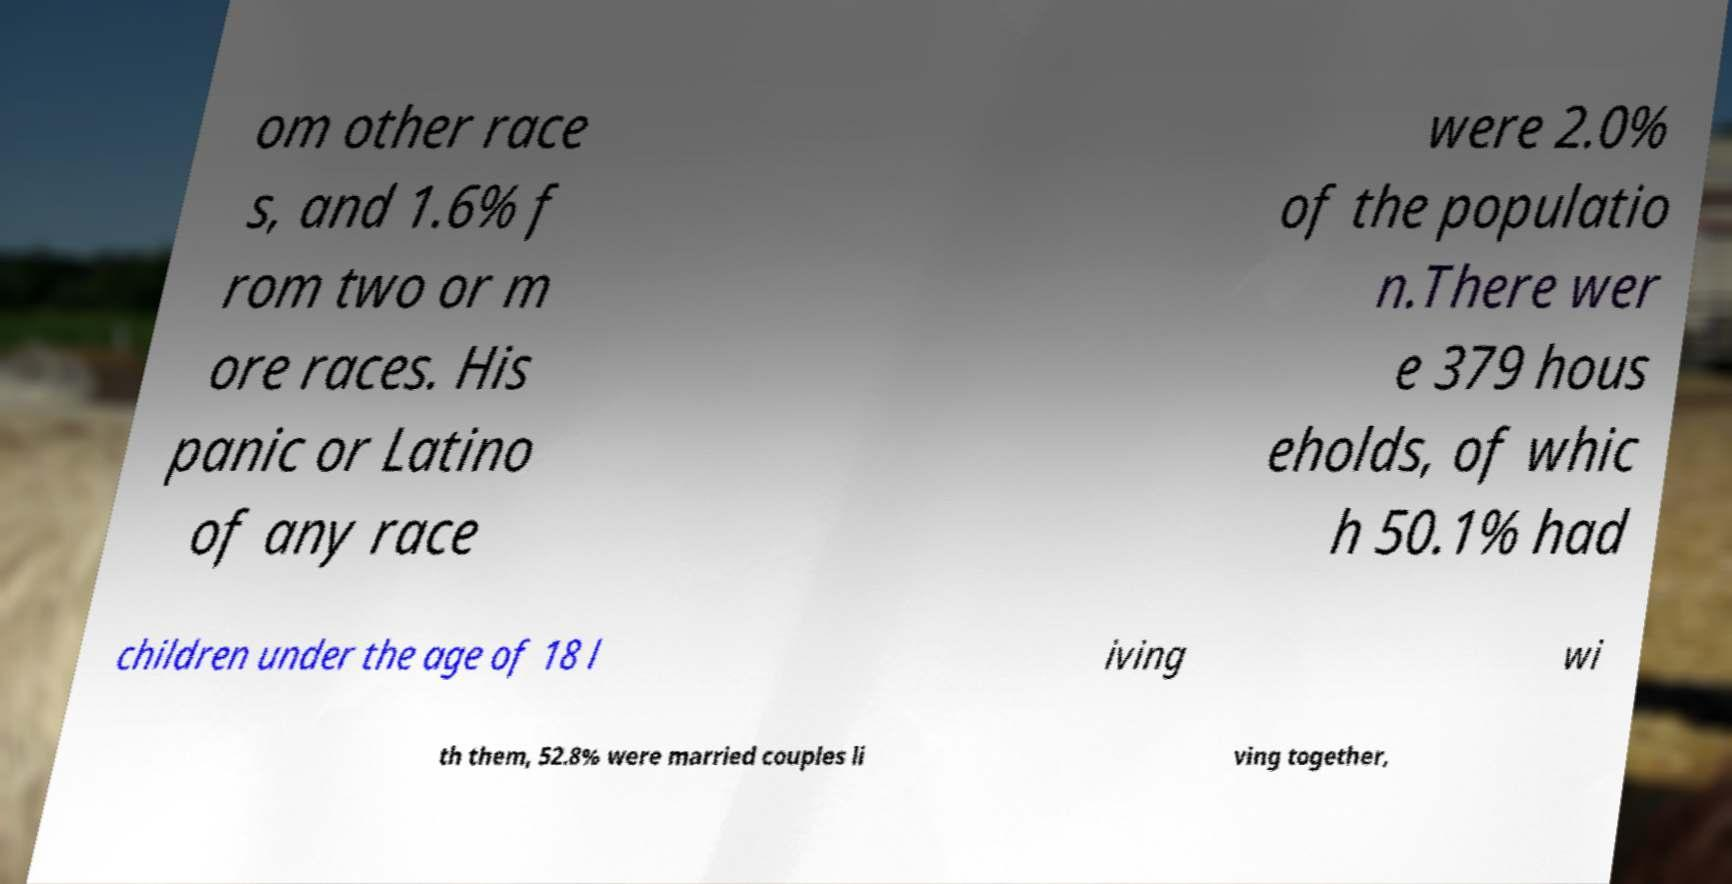For documentation purposes, I need the text within this image transcribed. Could you provide that? om other race s, and 1.6% f rom two or m ore races. His panic or Latino of any race were 2.0% of the populatio n.There wer e 379 hous eholds, of whic h 50.1% had children under the age of 18 l iving wi th them, 52.8% were married couples li ving together, 